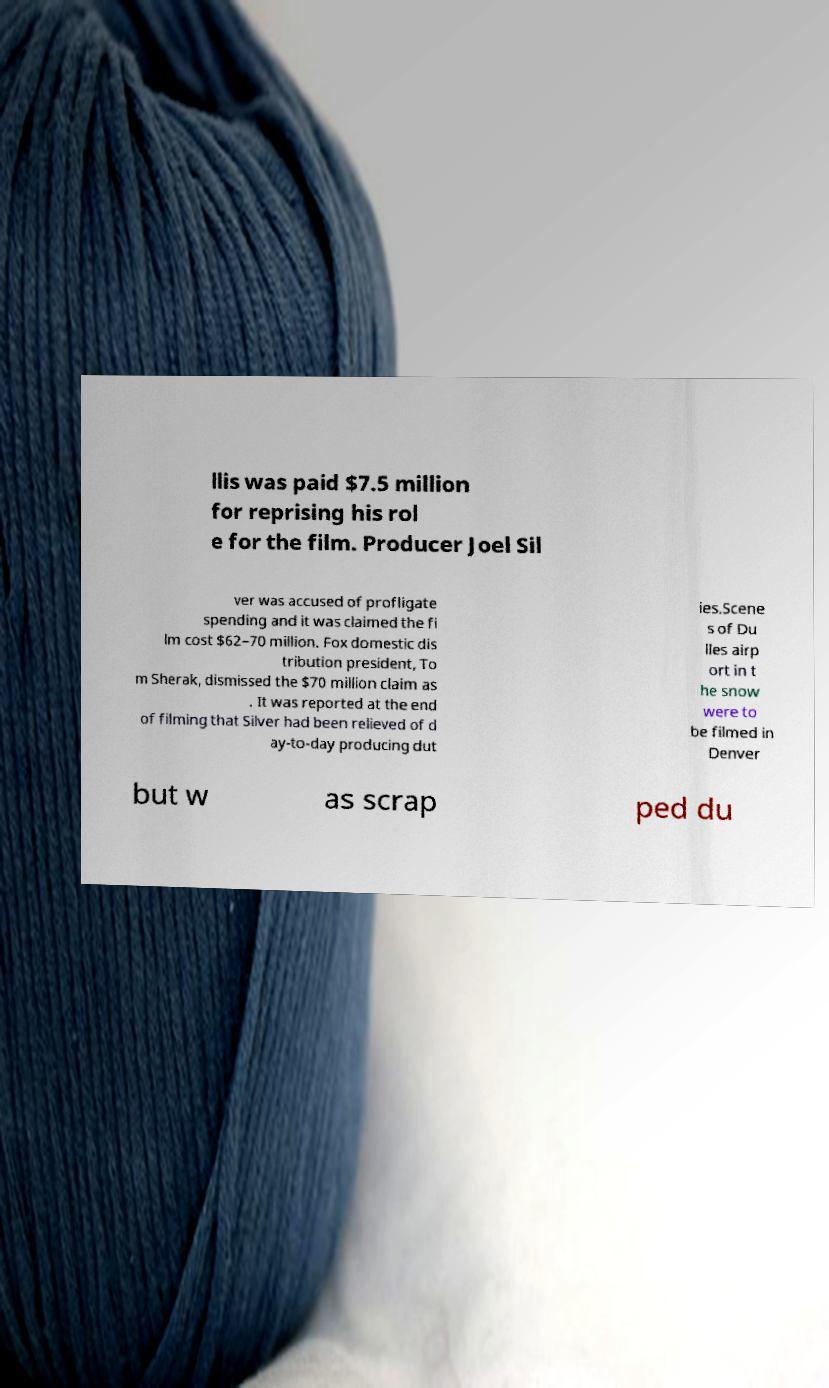Please read and relay the text visible in this image. What does it say? llis was paid $7.5 million for reprising his rol e for the film. Producer Joel Sil ver was accused of profligate spending and it was claimed the fi lm cost $62–70 million. Fox domestic dis tribution president, To m Sherak, dismissed the $70 million claim as . It was reported at the end of filming that Silver had been relieved of d ay-to-day producing dut ies.Scene s of Du lles airp ort in t he snow were to be filmed in Denver but w as scrap ped du 